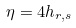<formula> <loc_0><loc_0><loc_500><loc_500>\eta = 4 h _ { r , s }</formula> 